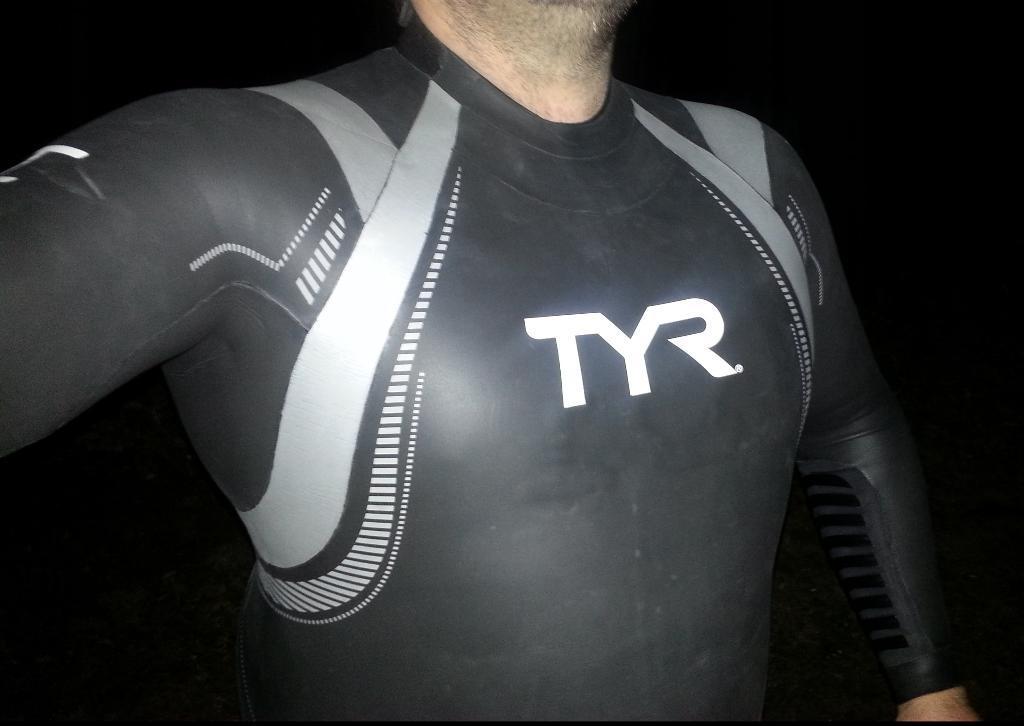In one or two sentences, can you explain what this image depicts? In this image we can see a person truncated and the background is dark. 